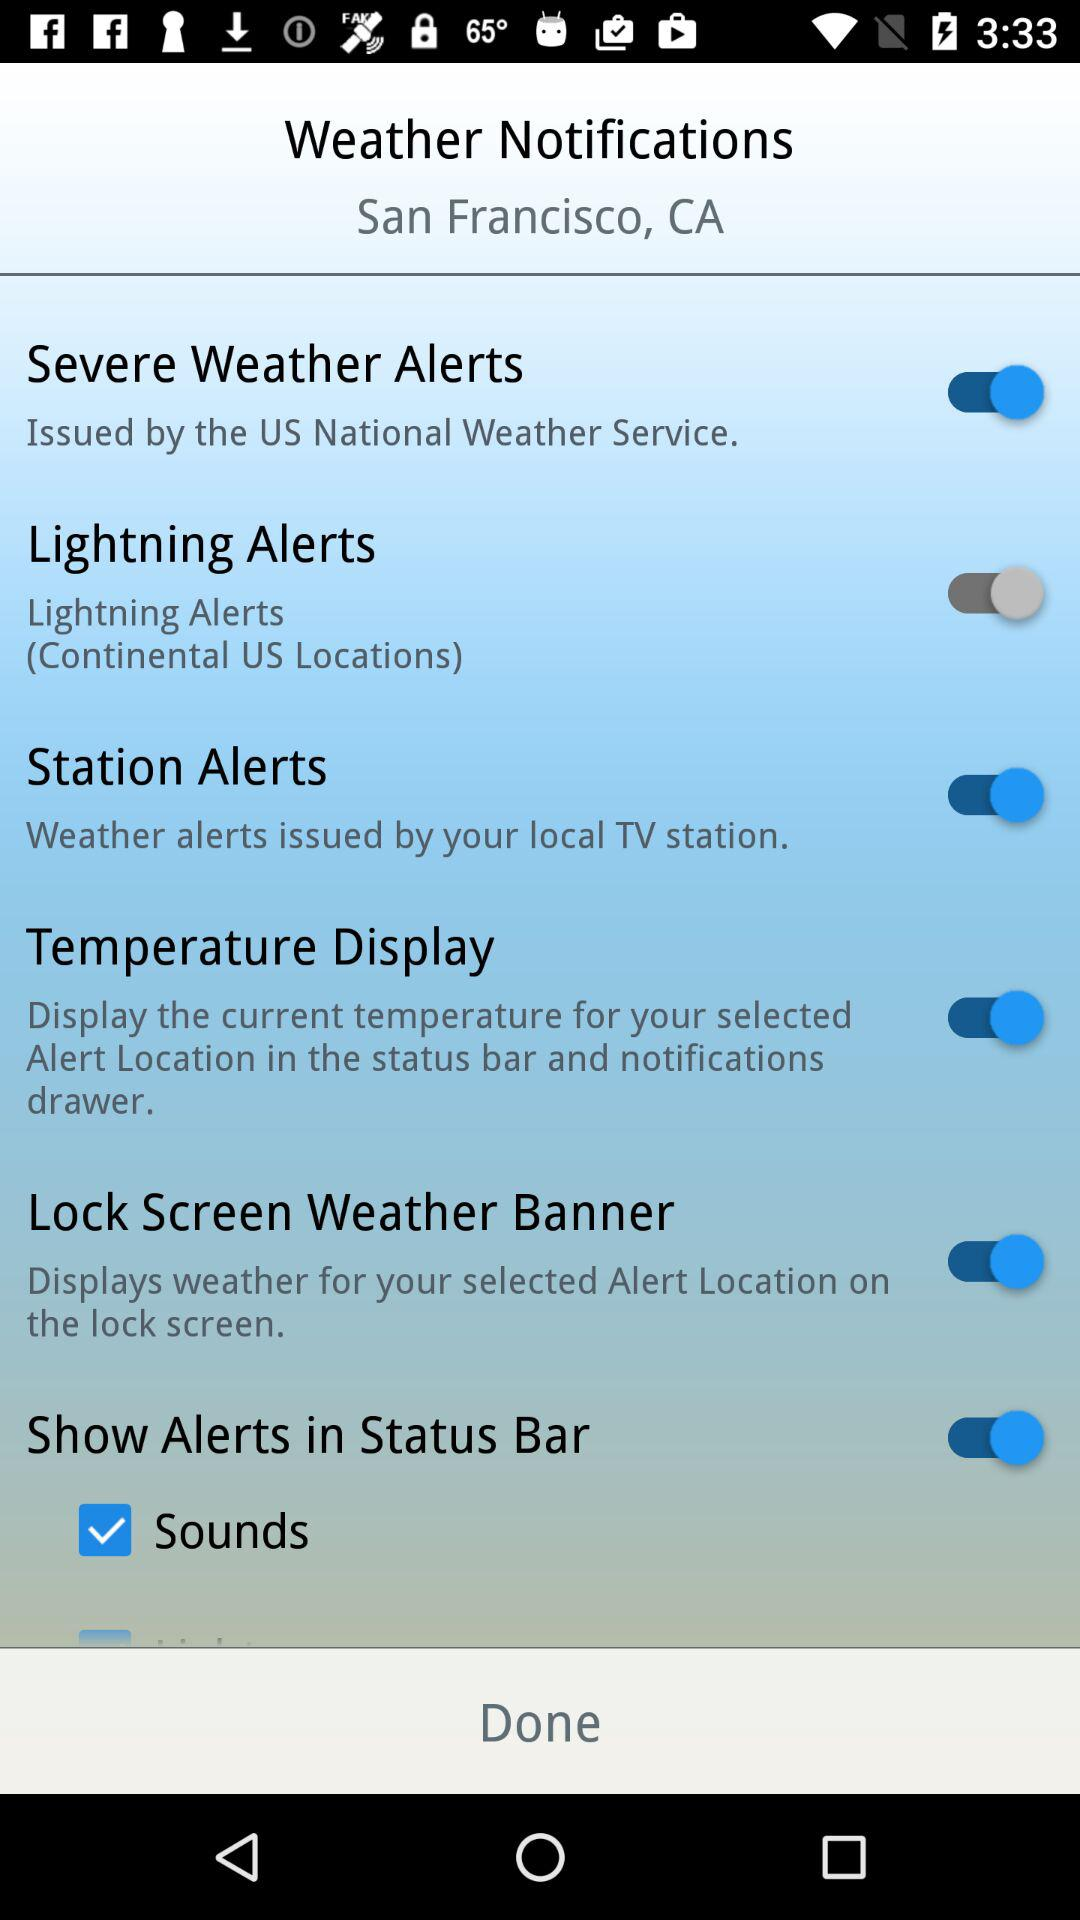Which options are disabled?
When the provided information is insufficient, respond with <no answer>. <no answer> 